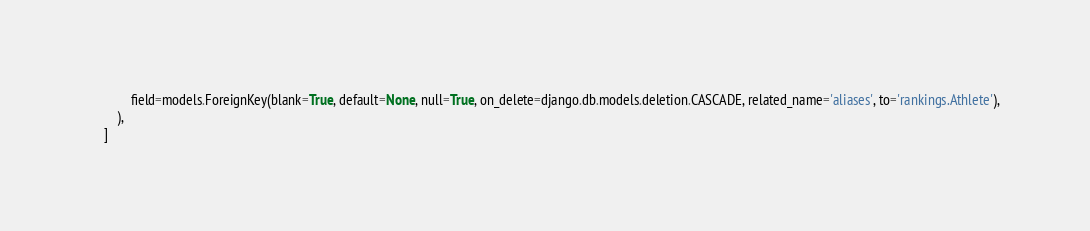<code> <loc_0><loc_0><loc_500><loc_500><_Python_>            field=models.ForeignKey(blank=True, default=None, null=True, on_delete=django.db.models.deletion.CASCADE, related_name='aliases', to='rankings.Athlete'),
        ),
    ]
</code> 